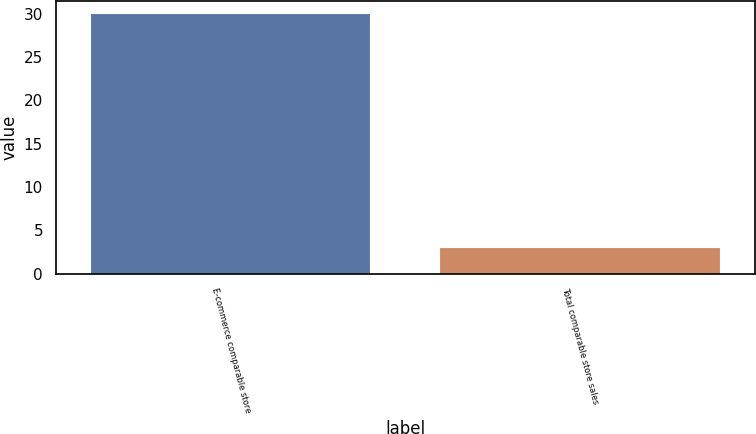<chart> <loc_0><loc_0><loc_500><loc_500><bar_chart><fcel>E-commerce comparable store<fcel>Total comparable store sales<nl><fcel>30<fcel>3<nl></chart> 